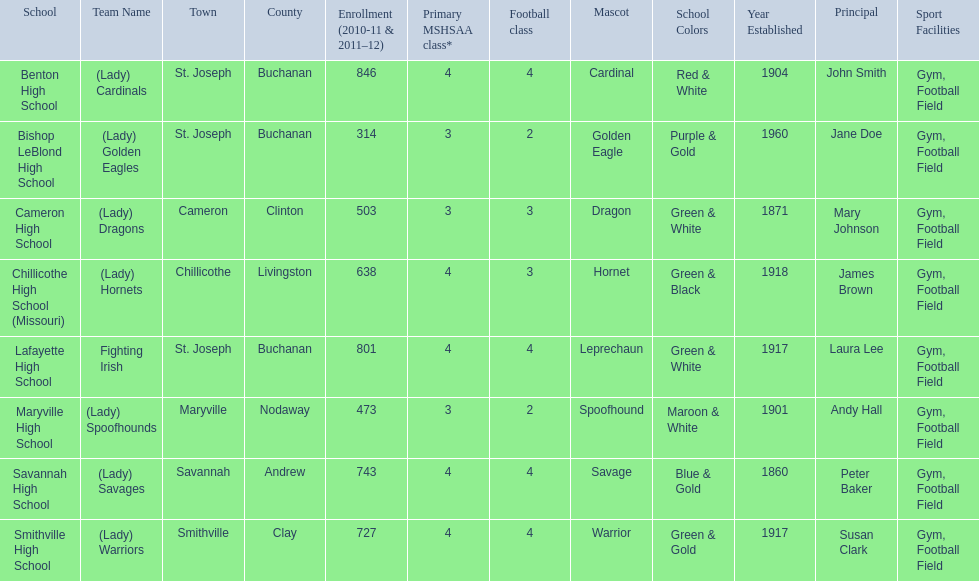How many are enrolled at each school? Benton High School, 846, Bishop LeBlond High School, 314, Cameron High School, 503, Chillicothe High School (Missouri), 638, Lafayette High School, 801, Maryville High School, 473, Savannah High School, 743, Smithville High School, 727. Which school has at only three football classes? Cameron High School, 3, Chillicothe High School (Missouri), 3. Which school has 638 enrolled and 3 football classes? Chillicothe High School (Missouri). 